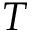<formula> <loc_0><loc_0><loc_500><loc_500>T</formula> 